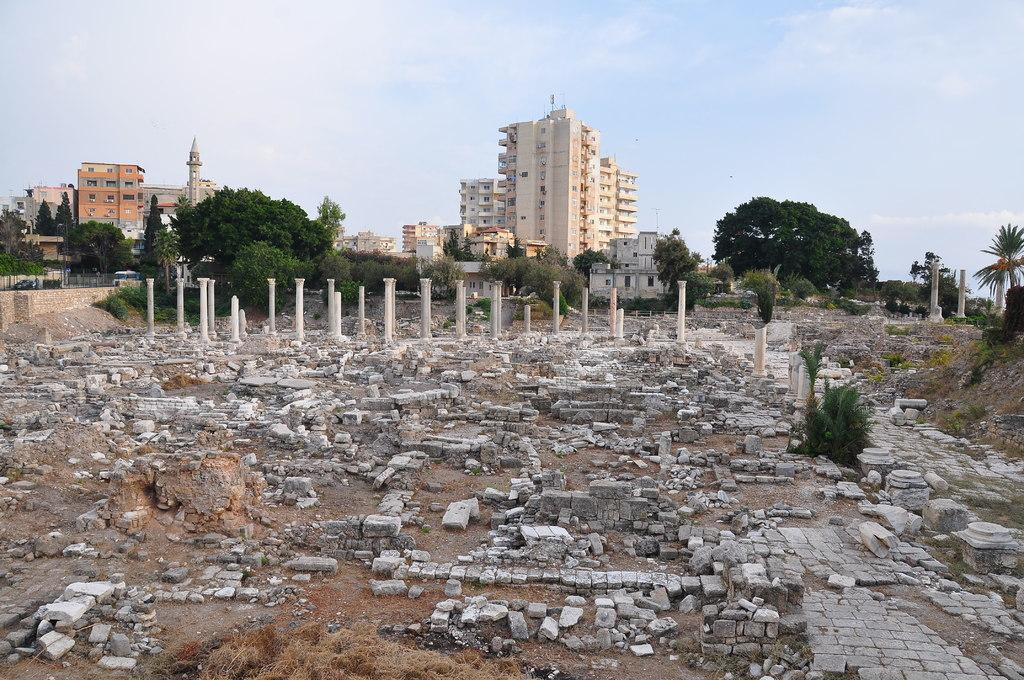What type of structures can be seen in the image? There are buildings in the image. What type of vegetation is present in the image? There are trees in the image. What objects are standing upright in the image? There are poles in the image. What type of ground coverings can be seen in the image? There are stones and marbles on the ground in the image. Can you tell me how many bones are scattered on the ground in the image? There are no bones present in the image; it features stones and marbles on the ground. What type of soap is visible on the poles in the image? There is no soap present in the image; it only features buildings, trees, poles, stones, and marbles. 